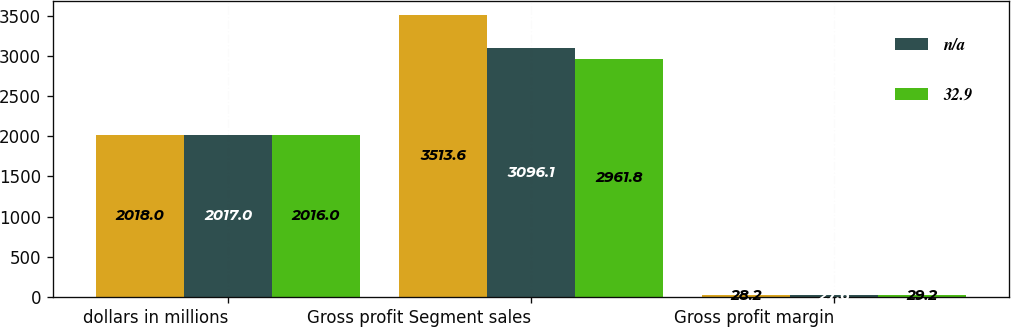Convert chart to OTSL. <chart><loc_0><loc_0><loc_500><loc_500><stacked_bar_chart><ecel><fcel>dollars in millions<fcel>Gross profit Segment sales<fcel>Gross profit margin<nl><fcel>nan<fcel>2018<fcel>3513.6<fcel>28.2<nl><fcel>nan<fcel>2017<fcel>3096.1<fcel>27.6<nl><fcel>32.9<fcel>2016<fcel>2961.8<fcel>29.2<nl></chart> 